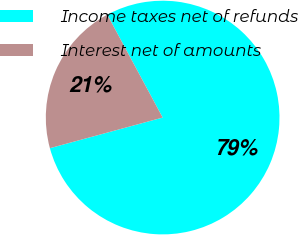Convert chart. <chart><loc_0><loc_0><loc_500><loc_500><pie_chart><fcel>Income taxes net of refunds<fcel>Interest net of amounts<nl><fcel>78.64%<fcel>21.36%<nl></chart> 